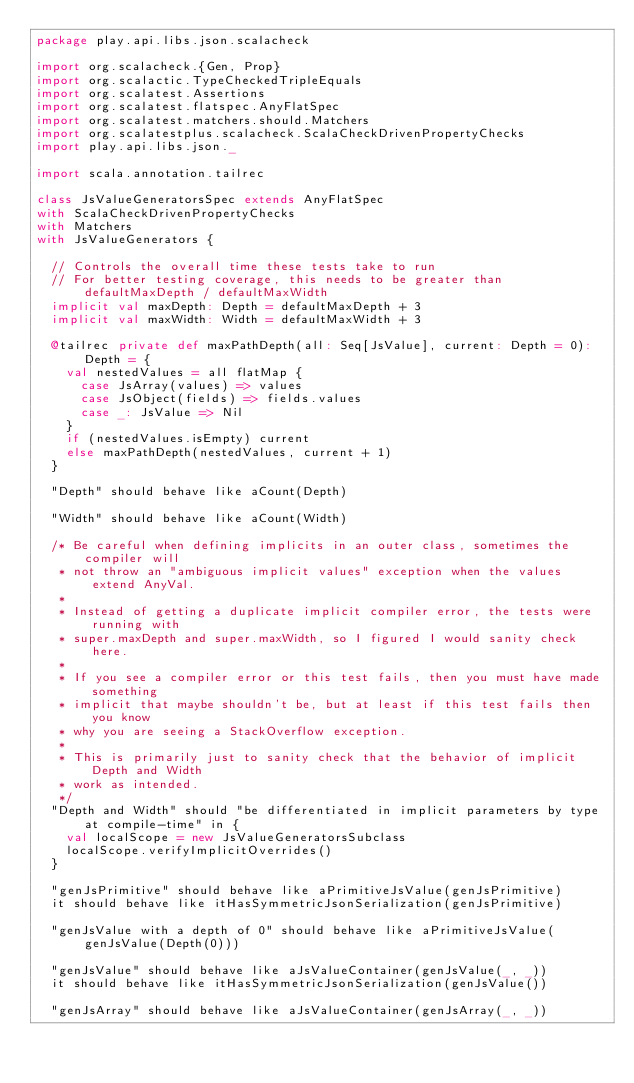<code> <loc_0><loc_0><loc_500><loc_500><_Scala_>package play.api.libs.json.scalacheck

import org.scalacheck.{Gen, Prop}
import org.scalactic.TypeCheckedTripleEquals
import org.scalatest.Assertions
import org.scalatest.flatspec.AnyFlatSpec
import org.scalatest.matchers.should.Matchers
import org.scalatestplus.scalacheck.ScalaCheckDrivenPropertyChecks
import play.api.libs.json._

import scala.annotation.tailrec

class JsValueGeneratorsSpec extends AnyFlatSpec
with ScalaCheckDrivenPropertyChecks
with Matchers
with JsValueGenerators {

  // Controls the overall time these tests take to run
  // For better testing coverage, this needs to be greater than defaultMaxDepth / defaultMaxWidth
  implicit val maxDepth: Depth = defaultMaxDepth + 3
  implicit val maxWidth: Width = defaultMaxWidth + 3

  @tailrec private def maxPathDepth(all: Seq[JsValue], current: Depth = 0): Depth = {
    val nestedValues = all flatMap {
      case JsArray(values) => values
      case JsObject(fields) => fields.values
      case _: JsValue => Nil
    }
    if (nestedValues.isEmpty) current
    else maxPathDepth(nestedValues, current + 1)
  }

  "Depth" should behave like aCount(Depth)

  "Width" should behave like aCount(Width)

  /* Be careful when defining implicits in an outer class, sometimes the compiler will
   * not throw an "ambiguous implicit values" exception when the values extend AnyVal.
   *
   * Instead of getting a duplicate implicit compiler error, the tests were running with
   * super.maxDepth and super.maxWidth, so I figured I would sanity check here.
   *
   * If you see a compiler error or this test fails, then you must have made something
   * implicit that maybe shouldn't be, but at least if this test fails then you know
   * why you are seeing a StackOverflow exception.
   *
   * This is primarily just to sanity check that the behavior of implicit Depth and Width
   * work as intended.
   */
  "Depth and Width" should "be differentiated in implicit parameters by type at compile-time" in {
    val localScope = new JsValueGeneratorsSubclass
    localScope.verifyImplicitOverrides()
  }

  "genJsPrimitive" should behave like aPrimitiveJsValue(genJsPrimitive)
  it should behave like itHasSymmetricJsonSerialization(genJsPrimitive)

  "genJsValue with a depth of 0" should behave like aPrimitiveJsValue(genJsValue(Depth(0)))

  "genJsValue" should behave like aJsValueContainer(genJsValue(_, _))
  it should behave like itHasSymmetricJsonSerialization(genJsValue())

  "genJsArray" should behave like aJsValueContainer(genJsArray(_, _))</code> 